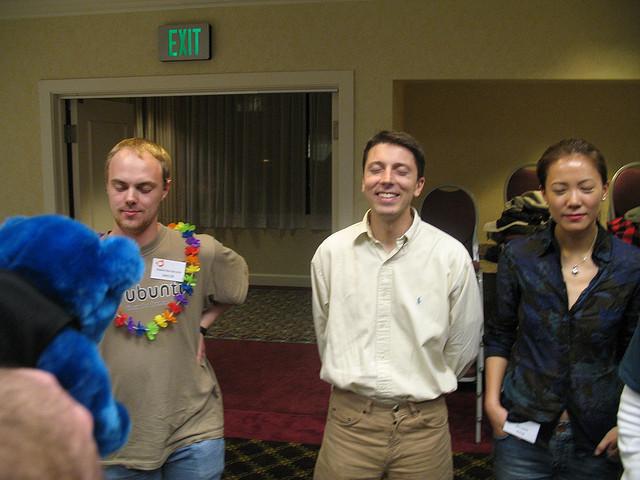What does the person on the left have around his neck?
Short answer required. Lei. How many women in the photo?
Quick response, please. 1. What does the sign above the door say?
Concise answer only. Exit. 